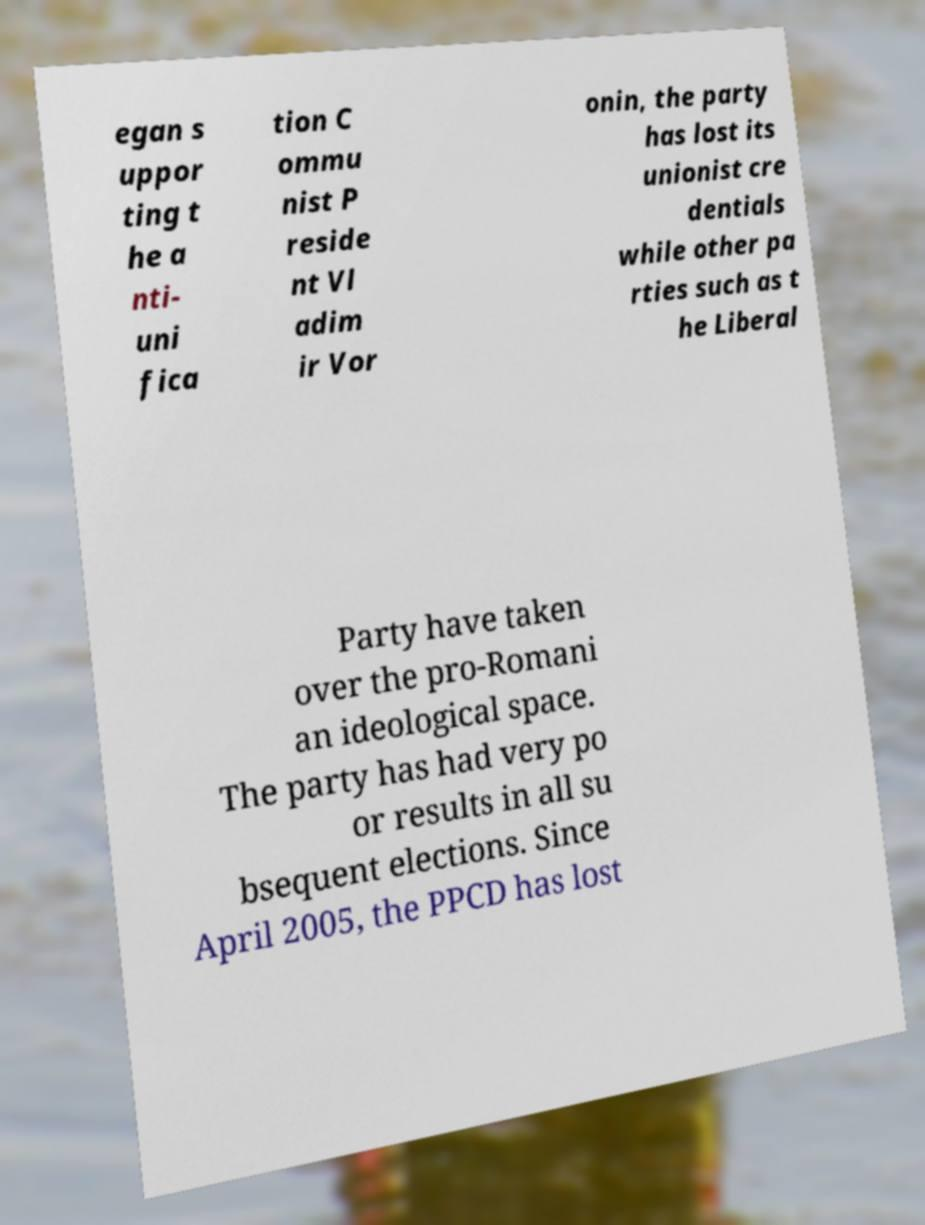There's text embedded in this image that I need extracted. Can you transcribe it verbatim? egan s uppor ting t he a nti- uni fica tion C ommu nist P reside nt Vl adim ir Vor onin, the party has lost its unionist cre dentials while other pa rties such as t he Liberal Party have taken over the pro-Romani an ideological space. The party has had very po or results in all su bsequent elections. Since April 2005, the PPCD has lost 